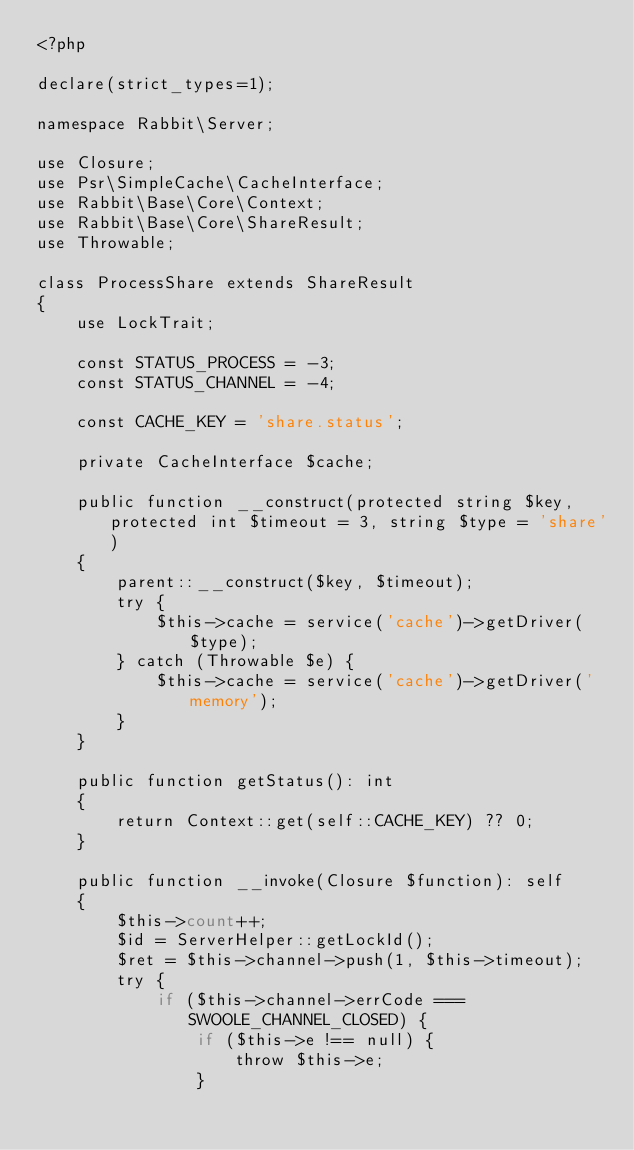<code> <loc_0><loc_0><loc_500><loc_500><_PHP_><?php

declare(strict_types=1);

namespace Rabbit\Server;

use Closure;
use Psr\SimpleCache\CacheInterface;
use Rabbit\Base\Core\Context;
use Rabbit\Base\Core\ShareResult;
use Throwable;

class ProcessShare extends ShareResult
{
    use LockTrait;

    const STATUS_PROCESS = -3;
    const STATUS_CHANNEL = -4;

    const CACHE_KEY = 'share.status';

    private CacheInterface $cache;

    public function __construct(protected string $key, protected int $timeout = 3, string $type = 'share')
    {
        parent::__construct($key, $timeout);
        try {
            $this->cache = service('cache')->getDriver($type);
        } catch (Throwable $e) {
            $this->cache = service('cache')->getDriver('memory');
        }
    }

    public function getStatus(): int
    {
        return Context::get(self::CACHE_KEY) ?? 0;
    }

    public function __invoke(Closure $function): self
    {
        $this->count++;
        $id = ServerHelper::getLockId();
        $ret = $this->channel->push(1, $this->timeout);
        try {
            if ($this->channel->errCode === SWOOLE_CHANNEL_CLOSED) {
                if ($this->e !== null) {
                    throw $this->e;
                }</code> 